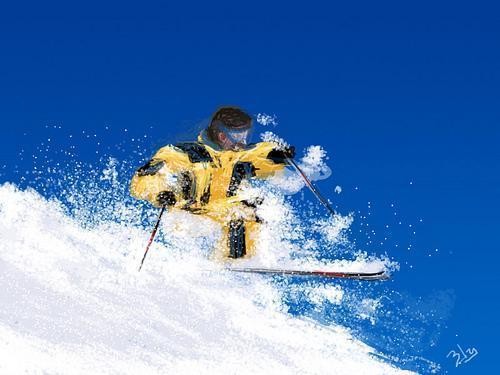How many poles are there?
Give a very brief answer. 2. 